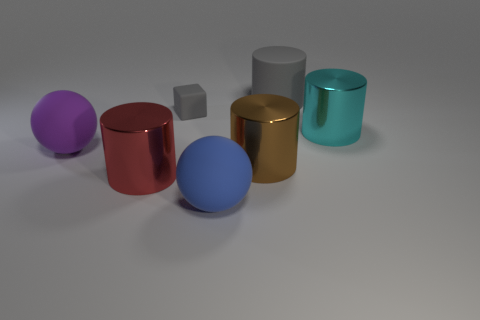Subtract 2 cylinders. How many cylinders are left? 2 Subtract all cylinders. How many objects are left? 3 Add 1 cyan metal objects. How many objects exist? 8 Subtract all tiny gray matte cubes. Subtract all blue spheres. How many objects are left? 5 Add 4 large balls. How many large balls are left? 6 Add 1 purple matte spheres. How many purple matte spheres exist? 2 Subtract 1 brown cylinders. How many objects are left? 6 